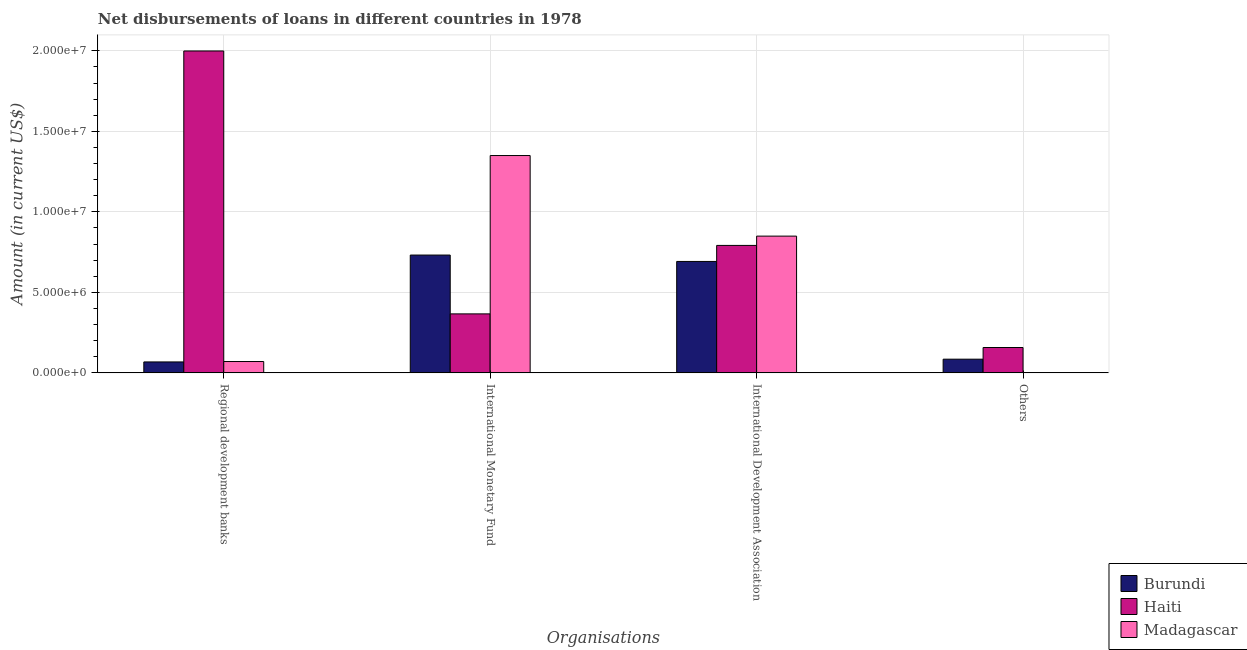How many bars are there on the 2nd tick from the right?
Ensure brevity in your answer.  3. What is the label of the 1st group of bars from the left?
Give a very brief answer. Regional development banks. What is the amount of loan disimbursed by international monetary fund in Madagascar?
Keep it short and to the point. 1.35e+07. Across all countries, what is the maximum amount of loan disimbursed by regional development banks?
Your response must be concise. 2.00e+07. In which country was the amount of loan disimbursed by international monetary fund maximum?
Keep it short and to the point. Madagascar. What is the total amount of loan disimbursed by other organisations in the graph?
Offer a terse response. 2.42e+06. What is the difference between the amount of loan disimbursed by other organisations in Haiti and that in Burundi?
Make the answer very short. 7.25e+05. What is the difference between the amount of loan disimbursed by regional development banks in Madagascar and the amount of loan disimbursed by international monetary fund in Haiti?
Ensure brevity in your answer.  -2.96e+06. What is the average amount of loan disimbursed by regional development banks per country?
Your answer should be compact. 7.12e+06. What is the difference between the amount of loan disimbursed by other organisations and amount of loan disimbursed by international development association in Haiti?
Provide a short and direct response. -6.34e+06. What is the ratio of the amount of loan disimbursed by international monetary fund in Burundi to that in Madagascar?
Keep it short and to the point. 0.54. What is the difference between the highest and the second highest amount of loan disimbursed by regional development banks?
Give a very brief answer. 1.93e+07. What is the difference between the highest and the lowest amount of loan disimbursed by regional development banks?
Offer a terse response. 1.93e+07. In how many countries, is the amount of loan disimbursed by international monetary fund greater than the average amount of loan disimbursed by international monetary fund taken over all countries?
Offer a terse response. 1. Is it the case that in every country, the sum of the amount of loan disimbursed by international monetary fund and amount of loan disimbursed by regional development banks is greater than the sum of amount of loan disimbursed by other organisations and amount of loan disimbursed by international development association?
Ensure brevity in your answer.  No. Is it the case that in every country, the sum of the amount of loan disimbursed by regional development banks and amount of loan disimbursed by international monetary fund is greater than the amount of loan disimbursed by international development association?
Offer a terse response. Yes. How many bars are there?
Give a very brief answer. 11. Are all the bars in the graph horizontal?
Make the answer very short. No. What is the difference between two consecutive major ticks on the Y-axis?
Ensure brevity in your answer.  5.00e+06. Does the graph contain any zero values?
Your response must be concise. Yes. How many legend labels are there?
Keep it short and to the point. 3. What is the title of the graph?
Your response must be concise. Net disbursements of loans in different countries in 1978. What is the label or title of the X-axis?
Ensure brevity in your answer.  Organisations. What is the Amount (in current US$) in Burundi in Regional development banks?
Provide a short and direct response. 6.79e+05. What is the Amount (in current US$) in Haiti in Regional development banks?
Your answer should be compact. 2.00e+07. What is the Amount (in current US$) of Madagascar in Regional development banks?
Your response must be concise. 7.04e+05. What is the Amount (in current US$) of Burundi in International Monetary Fund?
Provide a short and direct response. 7.32e+06. What is the Amount (in current US$) in Haiti in International Monetary Fund?
Keep it short and to the point. 3.66e+06. What is the Amount (in current US$) of Madagascar in International Monetary Fund?
Your answer should be very brief. 1.35e+07. What is the Amount (in current US$) in Burundi in International Development Association?
Offer a terse response. 6.92e+06. What is the Amount (in current US$) in Haiti in International Development Association?
Offer a terse response. 7.92e+06. What is the Amount (in current US$) in Madagascar in International Development Association?
Keep it short and to the point. 8.49e+06. What is the Amount (in current US$) of Burundi in Others?
Your answer should be very brief. 8.50e+05. What is the Amount (in current US$) of Haiti in Others?
Ensure brevity in your answer.  1.58e+06. Across all Organisations, what is the maximum Amount (in current US$) of Burundi?
Give a very brief answer. 7.32e+06. Across all Organisations, what is the maximum Amount (in current US$) of Haiti?
Ensure brevity in your answer.  2.00e+07. Across all Organisations, what is the maximum Amount (in current US$) in Madagascar?
Ensure brevity in your answer.  1.35e+07. Across all Organisations, what is the minimum Amount (in current US$) in Burundi?
Keep it short and to the point. 6.79e+05. Across all Organisations, what is the minimum Amount (in current US$) in Haiti?
Offer a very short reply. 1.58e+06. Across all Organisations, what is the minimum Amount (in current US$) of Madagascar?
Offer a very short reply. 0. What is the total Amount (in current US$) in Burundi in the graph?
Your response must be concise. 1.58e+07. What is the total Amount (in current US$) in Haiti in the graph?
Offer a very short reply. 3.31e+07. What is the total Amount (in current US$) of Madagascar in the graph?
Provide a succinct answer. 2.27e+07. What is the difference between the Amount (in current US$) in Burundi in Regional development banks and that in International Monetary Fund?
Your response must be concise. -6.64e+06. What is the difference between the Amount (in current US$) of Haiti in Regional development banks and that in International Monetary Fund?
Make the answer very short. 1.63e+07. What is the difference between the Amount (in current US$) of Madagascar in Regional development banks and that in International Monetary Fund?
Make the answer very short. -1.28e+07. What is the difference between the Amount (in current US$) of Burundi in Regional development banks and that in International Development Association?
Offer a very short reply. -6.24e+06. What is the difference between the Amount (in current US$) of Haiti in Regional development banks and that in International Development Association?
Make the answer very short. 1.21e+07. What is the difference between the Amount (in current US$) of Madagascar in Regional development banks and that in International Development Association?
Your answer should be very brief. -7.79e+06. What is the difference between the Amount (in current US$) in Burundi in Regional development banks and that in Others?
Your answer should be compact. -1.71e+05. What is the difference between the Amount (in current US$) in Haiti in Regional development banks and that in Others?
Offer a very short reply. 1.84e+07. What is the difference between the Amount (in current US$) of Burundi in International Monetary Fund and that in International Development Association?
Your response must be concise. 3.97e+05. What is the difference between the Amount (in current US$) of Haiti in International Monetary Fund and that in International Development Association?
Provide a short and direct response. -4.25e+06. What is the difference between the Amount (in current US$) in Madagascar in International Monetary Fund and that in International Development Association?
Offer a terse response. 5.00e+06. What is the difference between the Amount (in current US$) of Burundi in International Monetary Fund and that in Others?
Provide a succinct answer. 6.47e+06. What is the difference between the Amount (in current US$) of Haiti in International Monetary Fund and that in Others?
Give a very brief answer. 2.09e+06. What is the difference between the Amount (in current US$) in Burundi in International Development Association and that in Others?
Your answer should be very brief. 6.07e+06. What is the difference between the Amount (in current US$) in Haiti in International Development Association and that in Others?
Keep it short and to the point. 6.34e+06. What is the difference between the Amount (in current US$) of Burundi in Regional development banks and the Amount (in current US$) of Haiti in International Monetary Fund?
Provide a succinct answer. -2.98e+06. What is the difference between the Amount (in current US$) in Burundi in Regional development banks and the Amount (in current US$) in Madagascar in International Monetary Fund?
Your answer should be very brief. -1.28e+07. What is the difference between the Amount (in current US$) in Haiti in Regional development banks and the Amount (in current US$) in Madagascar in International Monetary Fund?
Provide a succinct answer. 6.49e+06. What is the difference between the Amount (in current US$) in Burundi in Regional development banks and the Amount (in current US$) in Haiti in International Development Association?
Ensure brevity in your answer.  -7.24e+06. What is the difference between the Amount (in current US$) of Burundi in Regional development banks and the Amount (in current US$) of Madagascar in International Development Association?
Make the answer very short. -7.81e+06. What is the difference between the Amount (in current US$) in Haiti in Regional development banks and the Amount (in current US$) in Madagascar in International Development Association?
Keep it short and to the point. 1.15e+07. What is the difference between the Amount (in current US$) in Burundi in Regional development banks and the Amount (in current US$) in Haiti in Others?
Your answer should be compact. -8.96e+05. What is the difference between the Amount (in current US$) of Burundi in International Monetary Fund and the Amount (in current US$) of Haiti in International Development Association?
Keep it short and to the point. -5.99e+05. What is the difference between the Amount (in current US$) in Burundi in International Monetary Fund and the Amount (in current US$) in Madagascar in International Development Association?
Give a very brief answer. -1.18e+06. What is the difference between the Amount (in current US$) in Haiti in International Monetary Fund and the Amount (in current US$) in Madagascar in International Development Association?
Provide a succinct answer. -4.83e+06. What is the difference between the Amount (in current US$) in Burundi in International Monetary Fund and the Amount (in current US$) in Haiti in Others?
Your response must be concise. 5.74e+06. What is the difference between the Amount (in current US$) in Burundi in International Development Association and the Amount (in current US$) in Haiti in Others?
Your answer should be very brief. 5.34e+06. What is the average Amount (in current US$) of Burundi per Organisations?
Your response must be concise. 3.94e+06. What is the average Amount (in current US$) of Haiti per Organisations?
Keep it short and to the point. 8.29e+06. What is the average Amount (in current US$) of Madagascar per Organisations?
Provide a short and direct response. 5.67e+06. What is the difference between the Amount (in current US$) in Burundi and Amount (in current US$) in Haiti in Regional development banks?
Offer a terse response. -1.93e+07. What is the difference between the Amount (in current US$) in Burundi and Amount (in current US$) in Madagascar in Regional development banks?
Make the answer very short. -2.50e+04. What is the difference between the Amount (in current US$) of Haiti and Amount (in current US$) of Madagascar in Regional development banks?
Give a very brief answer. 1.93e+07. What is the difference between the Amount (in current US$) of Burundi and Amount (in current US$) of Haiti in International Monetary Fund?
Provide a short and direct response. 3.65e+06. What is the difference between the Amount (in current US$) in Burundi and Amount (in current US$) in Madagascar in International Monetary Fund?
Provide a short and direct response. -6.18e+06. What is the difference between the Amount (in current US$) of Haiti and Amount (in current US$) of Madagascar in International Monetary Fund?
Offer a terse response. -9.83e+06. What is the difference between the Amount (in current US$) in Burundi and Amount (in current US$) in Haiti in International Development Association?
Make the answer very short. -9.96e+05. What is the difference between the Amount (in current US$) in Burundi and Amount (in current US$) in Madagascar in International Development Association?
Offer a terse response. -1.57e+06. What is the difference between the Amount (in current US$) in Haiti and Amount (in current US$) in Madagascar in International Development Association?
Your response must be concise. -5.77e+05. What is the difference between the Amount (in current US$) in Burundi and Amount (in current US$) in Haiti in Others?
Ensure brevity in your answer.  -7.25e+05. What is the ratio of the Amount (in current US$) in Burundi in Regional development banks to that in International Monetary Fund?
Offer a very short reply. 0.09. What is the ratio of the Amount (in current US$) of Haiti in Regional development banks to that in International Monetary Fund?
Give a very brief answer. 5.46. What is the ratio of the Amount (in current US$) of Madagascar in Regional development banks to that in International Monetary Fund?
Offer a very short reply. 0.05. What is the ratio of the Amount (in current US$) in Burundi in Regional development banks to that in International Development Association?
Keep it short and to the point. 0.1. What is the ratio of the Amount (in current US$) of Haiti in Regional development banks to that in International Development Association?
Give a very brief answer. 2.53. What is the ratio of the Amount (in current US$) of Madagascar in Regional development banks to that in International Development Association?
Provide a short and direct response. 0.08. What is the ratio of the Amount (in current US$) in Burundi in Regional development banks to that in Others?
Provide a short and direct response. 0.8. What is the ratio of the Amount (in current US$) of Haiti in Regional development banks to that in Others?
Keep it short and to the point. 12.69. What is the ratio of the Amount (in current US$) in Burundi in International Monetary Fund to that in International Development Association?
Offer a very short reply. 1.06. What is the ratio of the Amount (in current US$) of Haiti in International Monetary Fund to that in International Development Association?
Offer a terse response. 0.46. What is the ratio of the Amount (in current US$) of Madagascar in International Monetary Fund to that in International Development Association?
Keep it short and to the point. 1.59. What is the ratio of the Amount (in current US$) in Burundi in International Monetary Fund to that in Others?
Ensure brevity in your answer.  8.61. What is the ratio of the Amount (in current US$) of Haiti in International Monetary Fund to that in Others?
Offer a terse response. 2.33. What is the ratio of the Amount (in current US$) in Burundi in International Development Association to that in Others?
Your response must be concise. 8.14. What is the ratio of the Amount (in current US$) of Haiti in International Development Association to that in Others?
Your answer should be compact. 5.03. What is the difference between the highest and the second highest Amount (in current US$) in Burundi?
Offer a terse response. 3.97e+05. What is the difference between the highest and the second highest Amount (in current US$) in Haiti?
Your answer should be very brief. 1.21e+07. What is the difference between the highest and the second highest Amount (in current US$) of Madagascar?
Provide a succinct answer. 5.00e+06. What is the difference between the highest and the lowest Amount (in current US$) of Burundi?
Make the answer very short. 6.64e+06. What is the difference between the highest and the lowest Amount (in current US$) of Haiti?
Ensure brevity in your answer.  1.84e+07. What is the difference between the highest and the lowest Amount (in current US$) in Madagascar?
Offer a very short reply. 1.35e+07. 